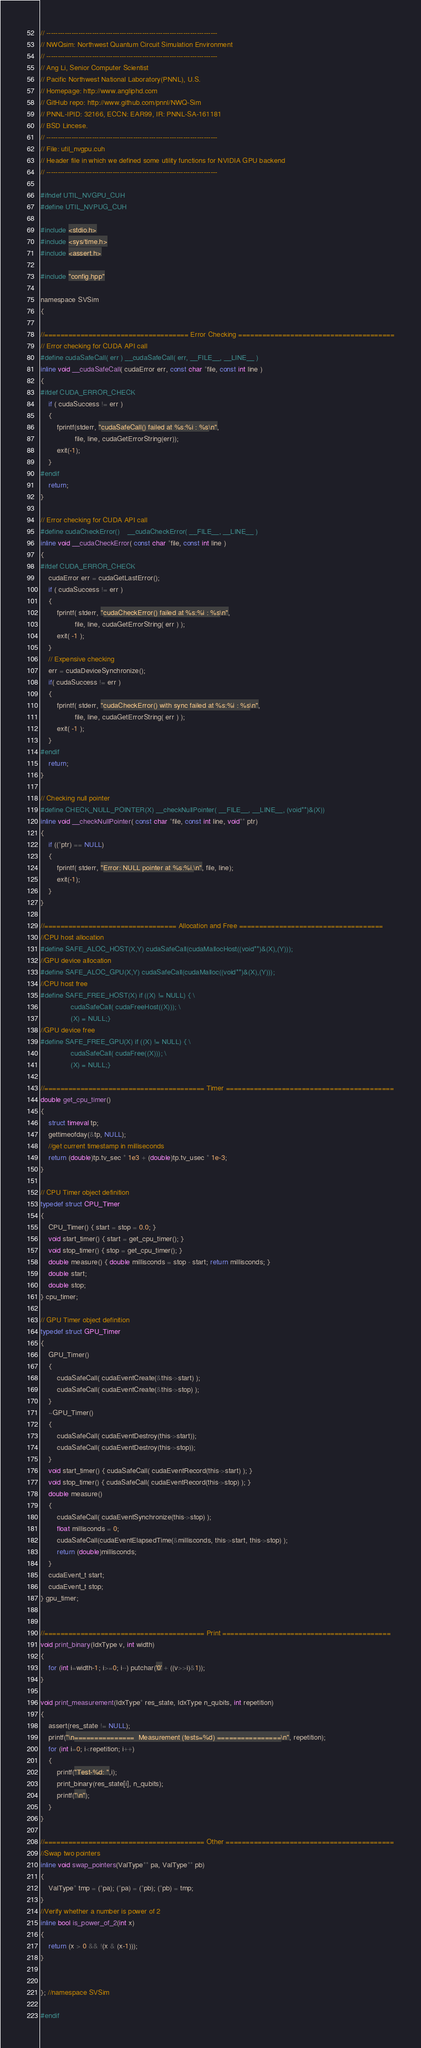<code> <loc_0><loc_0><loc_500><loc_500><_Cuda_>// ---------------------------------------------------------------------------
// NWQsim: Northwest Quantum Circuit Simulation Environment
// ---------------------------------------------------------------------------
// Ang Li, Senior Computer Scientist
// Pacific Northwest National Laboratory(PNNL), U.S.
// Homepage: http://www.angliphd.com
// GitHub repo: http://www.github.com/pnnl/NWQ-Sim
// PNNL-IPID: 32166, ECCN: EAR99, IR: PNNL-SA-161181
// BSD Lincese.
// ---------------------------------------------------------------------------
// File: util_nvgpu.cuh
// Header file in which we defined some utility functions for NVIDIA GPU backend
// ---------------------------------------------------------------------------

#ifndef UTIL_NVGPU_CUH
#define UTIL_NVPUG_CUH

#include <stdio.h>
#include <sys/time.h>
#include <assert.h>

#include "config.hpp"

namespace SVSim
{

//==================================== Error Checking =======================================
// Error checking for CUDA API call
#define cudaSafeCall( err ) __cudaSafeCall( err, __FILE__, __LINE__ )
inline void __cudaSafeCall( cudaError err, const char *file, const int line )
{
#ifdef CUDA_ERROR_CHECK
    if ( cudaSuccess != err )
    {
        fprintf(stderr, "cudaSafeCall() failed at %s:%i : %s\n",
                 file, line, cudaGetErrorString(err));
        exit(-1);
    }
#endif
    return;
}

// Error checking for CUDA API call
#define cudaCheckError()    __cudaCheckError( __FILE__, __LINE__ )
inline void __cudaCheckError( const char *file, const int line )
{
#ifdef CUDA_ERROR_CHECK
    cudaError err = cudaGetLastError();
    if ( cudaSuccess != err )
    {
        fprintf( stderr, "cudaCheckError() failed at %s:%i : %s\n",
                 file, line, cudaGetErrorString( err ) );
        exit( -1 );
    }
    // Expensive checking
    err = cudaDeviceSynchronize();
    if( cudaSuccess != err )
    {
        fprintf( stderr, "cudaCheckError() with sync failed at %s:%i : %s\n",
                 file, line, cudaGetErrorString( err ) );
        exit( -1 );
    }
#endif
    return;
}

// Checking null pointer
#define CHECK_NULL_POINTER(X) __checkNullPointer( __FILE__, __LINE__, (void**)&(X))
inline void __checkNullPointer( const char *file, const int line, void** ptr)
{
    if ((*ptr) == NULL)
    {
        fprintf( stderr, "Error: NULL pointer at %s:%i.\n", file, line);
        exit(-1);
    }
}

//================================= Allocation and Free ====================================
//CPU host allocation
#define SAFE_ALOC_HOST(X,Y) cudaSafeCall(cudaMallocHost((void**)&(X),(Y)));
//GPU device allocation
#define SAFE_ALOC_GPU(X,Y) cudaSafeCall(cudaMalloc((void**)&(X),(Y)));
//CPU host free
#define SAFE_FREE_HOST(X) if ((X) != NULL) { \
               cudaSafeCall( cudaFreeHost((X))); \
               (X) = NULL;}
//GPU device free
#define SAFE_FREE_GPU(X) if ((X) != NULL) { \
               cudaSafeCall( cudaFree((X))); \
               (X) = NULL;}

//======================================== Timer ==========================================
double get_cpu_timer()
{
    struct timeval tp;
    gettimeofday(&tp, NULL);
    //get current timestamp in milliseconds
    return (double)tp.tv_sec * 1e3 + (double)tp.tv_usec * 1e-3;
}

// CPU Timer object definition
typedef struct CPU_Timer
{
    CPU_Timer() { start = stop = 0.0; }
    void start_timer() { start = get_cpu_timer(); }
    void stop_timer() { stop = get_cpu_timer(); }
    double measure() { double millisconds = stop - start; return millisconds; }
    double start;
    double stop;
} cpu_timer;

// GPU Timer object definition
typedef struct GPU_Timer
{
    GPU_Timer()
    {
        cudaSafeCall( cudaEventCreate(&this->start) );
        cudaSafeCall( cudaEventCreate(&this->stop) );
    }
    ~GPU_Timer()
    {
        cudaSafeCall( cudaEventDestroy(this->start));
        cudaSafeCall( cudaEventDestroy(this->stop));
    }
    void start_timer() { cudaSafeCall( cudaEventRecord(this->start) ); }
    void stop_timer() { cudaSafeCall( cudaEventRecord(this->stop) ); }
    double measure()
    {
        cudaSafeCall( cudaEventSynchronize(this->stop) );
        float millisconds = 0;
        cudaSafeCall(cudaEventElapsedTime(&millisconds, this->start, this->stop) ); 
        return (double)millisconds;
    }
    cudaEvent_t start;
    cudaEvent_t stop;
} gpu_timer;


//======================================== Print ==========================================
void print_binary(IdxType v, int width)
{
    for (int i=width-1; i>=0; i--) putchar('0' + ((v>>i)&1));
}

void print_measurement(IdxType* res_state, IdxType n_qubits, int repetition)
{
    assert(res_state != NULL);
    printf("\n===============  Measurement (tests=%d) ================\n", repetition);
    for (int i=0; i<repetition; i++)
    {
        printf("Test-%d: ",i);
        print_binary(res_state[i], n_qubits);
        printf("\n");
    }
}

//======================================== Other ==========================================
//Swap two pointers
inline void swap_pointers(ValType** pa, ValType** pb)
{
    ValType* tmp = (*pa); (*pa) = (*pb); (*pb) = tmp;
}
//Verify whether a number is power of 2
inline bool is_power_of_2(int x)
{
    return (x > 0 && !(x & (x-1)));
}


}; //namespace SVSim

#endif
</code> 